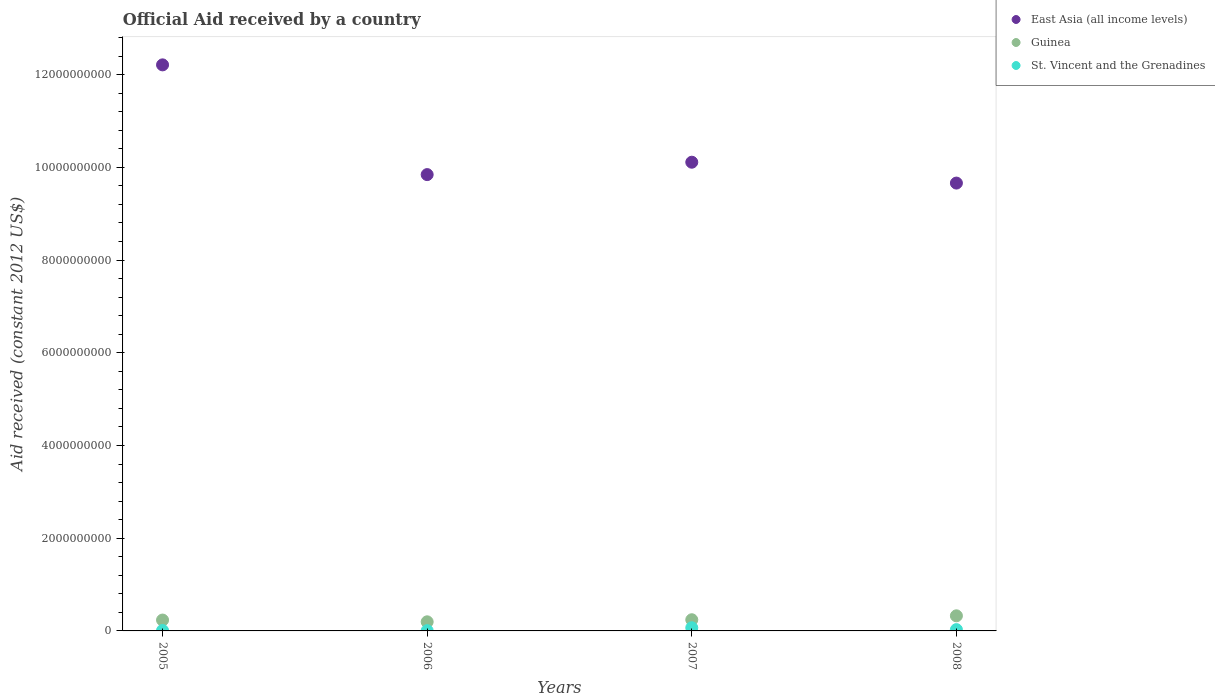How many different coloured dotlines are there?
Provide a short and direct response. 3. What is the net official aid received in St. Vincent and the Grenadines in 2007?
Offer a very short reply. 6.84e+07. Across all years, what is the maximum net official aid received in Guinea?
Your answer should be very brief. 3.26e+08. Across all years, what is the minimum net official aid received in St. Vincent and the Grenadines?
Keep it short and to the point. 5.68e+06. What is the total net official aid received in St. Vincent and the Grenadines in the graph?
Give a very brief answer. 1.12e+08. What is the difference between the net official aid received in Guinea in 2005 and that in 2006?
Provide a succinct answer. 3.81e+07. What is the difference between the net official aid received in Guinea in 2005 and the net official aid received in St. Vincent and the Grenadines in 2008?
Your answer should be compact. 2.06e+08. What is the average net official aid received in St. Vincent and the Grenadines per year?
Provide a short and direct response. 2.80e+07. In the year 2006, what is the difference between the net official aid received in East Asia (all income levels) and net official aid received in St. Vincent and the Grenadines?
Make the answer very short. 9.84e+09. In how many years, is the net official aid received in East Asia (all income levels) greater than 1200000000 US$?
Keep it short and to the point. 4. What is the ratio of the net official aid received in St. Vincent and the Grenadines in 2005 to that in 2006?
Keep it short and to the point. 1.72. Is the net official aid received in St. Vincent and the Grenadines in 2005 less than that in 2007?
Your answer should be compact. Yes. Is the difference between the net official aid received in East Asia (all income levels) in 2006 and 2008 greater than the difference between the net official aid received in St. Vincent and the Grenadines in 2006 and 2008?
Ensure brevity in your answer.  Yes. What is the difference between the highest and the second highest net official aid received in Guinea?
Provide a short and direct response. 8.46e+07. What is the difference between the highest and the lowest net official aid received in East Asia (all income levels)?
Provide a succinct answer. 2.55e+09. In how many years, is the net official aid received in St. Vincent and the Grenadines greater than the average net official aid received in St. Vincent and the Grenadines taken over all years?
Your answer should be very brief. 2. Is the sum of the net official aid received in St. Vincent and the Grenadines in 2007 and 2008 greater than the maximum net official aid received in Guinea across all years?
Ensure brevity in your answer.  No. Does the net official aid received in Guinea monotonically increase over the years?
Your answer should be very brief. No. Does the graph contain any zero values?
Give a very brief answer. No. Does the graph contain grids?
Your response must be concise. No. Where does the legend appear in the graph?
Offer a very short reply. Top right. How many legend labels are there?
Your answer should be very brief. 3. What is the title of the graph?
Ensure brevity in your answer.  Official Aid received by a country. What is the label or title of the Y-axis?
Offer a very short reply. Aid received (constant 2012 US$). What is the Aid received (constant 2012 US$) of East Asia (all income levels) in 2005?
Provide a short and direct response. 1.22e+1. What is the Aid received (constant 2012 US$) of Guinea in 2005?
Your response must be concise. 2.35e+08. What is the Aid received (constant 2012 US$) of St. Vincent and the Grenadines in 2005?
Your response must be concise. 9.75e+06. What is the Aid received (constant 2012 US$) of East Asia (all income levels) in 2006?
Ensure brevity in your answer.  9.84e+09. What is the Aid received (constant 2012 US$) of Guinea in 2006?
Your answer should be compact. 1.96e+08. What is the Aid received (constant 2012 US$) in St. Vincent and the Grenadines in 2006?
Give a very brief answer. 5.68e+06. What is the Aid received (constant 2012 US$) of East Asia (all income levels) in 2007?
Offer a terse response. 1.01e+1. What is the Aid received (constant 2012 US$) of Guinea in 2007?
Provide a succinct answer. 2.41e+08. What is the Aid received (constant 2012 US$) in St. Vincent and the Grenadines in 2007?
Give a very brief answer. 6.84e+07. What is the Aid received (constant 2012 US$) in East Asia (all income levels) in 2008?
Provide a succinct answer. 9.66e+09. What is the Aid received (constant 2012 US$) in Guinea in 2008?
Your answer should be very brief. 3.26e+08. What is the Aid received (constant 2012 US$) of St. Vincent and the Grenadines in 2008?
Make the answer very short. 2.82e+07. Across all years, what is the maximum Aid received (constant 2012 US$) in East Asia (all income levels)?
Your answer should be compact. 1.22e+1. Across all years, what is the maximum Aid received (constant 2012 US$) of Guinea?
Provide a short and direct response. 3.26e+08. Across all years, what is the maximum Aid received (constant 2012 US$) in St. Vincent and the Grenadines?
Offer a very short reply. 6.84e+07. Across all years, what is the minimum Aid received (constant 2012 US$) of East Asia (all income levels)?
Offer a very short reply. 9.66e+09. Across all years, what is the minimum Aid received (constant 2012 US$) of Guinea?
Give a very brief answer. 1.96e+08. Across all years, what is the minimum Aid received (constant 2012 US$) of St. Vincent and the Grenadines?
Your response must be concise. 5.68e+06. What is the total Aid received (constant 2012 US$) in East Asia (all income levels) in the graph?
Your answer should be very brief. 4.18e+1. What is the total Aid received (constant 2012 US$) of Guinea in the graph?
Offer a very short reply. 9.98e+08. What is the total Aid received (constant 2012 US$) in St. Vincent and the Grenadines in the graph?
Give a very brief answer. 1.12e+08. What is the difference between the Aid received (constant 2012 US$) in East Asia (all income levels) in 2005 and that in 2006?
Give a very brief answer. 2.37e+09. What is the difference between the Aid received (constant 2012 US$) in Guinea in 2005 and that in 2006?
Give a very brief answer. 3.81e+07. What is the difference between the Aid received (constant 2012 US$) of St. Vincent and the Grenadines in 2005 and that in 2006?
Your answer should be very brief. 4.07e+06. What is the difference between the Aid received (constant 2012 US$) in East Asia (all income levels) in 2005 and that in 2007?
Give a very brief answer. 2.10e+09. What is the difference between the Aid received (constant 2012 US$) in Guinea in 2005 and that in 2007?
Ensure brevity in your answer.  -6.56e+06. What is the difference between the Aid received (constant 2012 US$) of St. Vincent and the Grenadines in 2005 and that in 2007?
Provide a short and direct response. -5.87e+07. What is the difference between the Aid received (constant 2012 US$) of East Asia (all income levels) in 2005 and that in 2008?
Provide a succinct answer. 2.55e+09. What is the difference between the Aid received (constant 2012 US$) in Guinea in 2005 and that in 2008?
Provide a succinct answer. -9.11e+07. What is the difference between the Aid received (constant 2012 US$) of St. Vincent and the Grenadines in 2005 and that in 2008?
Offer a very short reply. -1.84e+07. What is the difference between the Aid received (constant 2012 US$) of East Asia (all income levels) in 2006 and that in 2007?
Keep it short and to the point. -2.67e+08. What is the difference between the Aid received (constant 2012 US$) in Guinea in 2006 and that in 2007?
Give a very brief answer. -4.46e+07. What is the difference between the Aid received (constant 2012 US$) in St. Vincent and the Grenadines in 2006 and that in 2007?
Your answer should be very brief. -6.27e+07. What is the difference between the Aid received (constant 2012 US$) of East Asia (all income levels) in 2006 and that in 2008?
Offer a terse response. 1.83e+08. What is the difference between the Aid received (constant 2012 US$) in Guinea in 2006 and that in 2008?
Offer a very short reply. -1.29e+08. What is the difference between the Aid received (constant 2012 US$) of St. Vincent and the Grenadines in 2006 and that in 2008?
Provide a succinct answer. -2.25e+07. What is the difference between the Aid received (constant 2012 US$) in East Asia (all income levels) in 2007 and that in 2008?
Make the answer very short. 4.50e+08. What is the difference between the Aid received (constant 2012 US$) in Guinea in 2007 and that in 2008?
Offer a very short reply. -8.46e+07. What is the difference between the Aid received (constant 2012 US$) of St. Vincent and the Grenadines in 2007 and that in 2008?
Offer a terse response. 4.02e+07. What is the difference between the Aid received (constant 2012 US$) in East Asia (all income levels) in 2005 and the Aid received (constant 2012 US$) in Guinea in 2006?
Your answer should be compact. 1.20e+1. What is the difference between the Aid received (constant 2012 US$) of East Asia (all income levels) in 2005 and the Aid received (constant 2012 US$) of St. Vincent and the Grenadines in 2006?
Keep it short and to the point. 1.22e+1. What is the difference between the Aid received (constant 2012 US$) of Guinea in 2005 and the Aid received (constant 2012 US$) of St. Vincent and the Grenadines in 2006?
Your response must be concise. 2.29e+08. What is the difference between the Aid received (constant 2012 US$) in East Asia (all income levels) in 2005 and the Aid received (constant 2012 US$) in Guinea in 2007?
Provide a short and direct response. 1.20e+1. What is the difference between the Aid received (constant 2012 US$) of East Asia (all income levels) in 2005 and the Aid received (constant 2012 US$) of St. Vincent and the Grenadines in 2007?
Offer a terse response. 1.21e+1. What is the difference between the Aid received (constant 2012 US$) of Guinea in 2005 and the Aid received (constant 2012 US$) of St. Vincent and the Grenadines in 2007?
Your answer should be very brief. 1.66e+08. What is the difference between the Aid received (constant 2012 US$) in East Asia (all income levels) in 2005 and the Aid received (constant 2012 US$) in Guinea in 2008?
Make the answer very short. 1.19e+1. What is the difference between the Aid received (constant 2012 US$) in East Asia (all income levels) in 2005 and the Aid received (constant 2012 US$) in St. Vincent and the Grenadines in 2008?
Your response must be concise. 1.22e+1. What is the difference between the Aid received (constant 2012 US$) in Guinea in 2005 and the Aid received (constant 2012 US$) in St. Vincent and the Grenadines in 2008?
Provide a short and direct response. 2.06e+08. What is the difference between the Aid received (constant 2012 US$) in East Asia (all income levels) in 2006 and the Aid received (constant 2012 US$) in Guinea in 2007?
Give a very brief answer. 9.60e+09. What is the difference between the Aid received (constant 2012 US$) of East Asia (all income levels) in 2006 and the Aid received (constant 2012 US$) of St. Vincent and the Grenadines in 2007?
Offer a terse response. 9.77e+09. What is the difference between the Aid received (constant 2012 US$) in Guinea in 2006 and the Aid received (constant 2012 US$) in St. Vincent and the Grenadines in 2007?
Your response must be concise. 1.28e+08. What is the difference between the Aid received (constant 2012 US$) of East Asia (all income levels) in 2006 and the Aid received (constant 2012 US$) of Guinea in 2008?
Keep it short and to the point. 9.52e+09. What is the difference between the Aid received (constant 2012 US$) in East Asia (all income levels) in 2006 and the Aid received (constant 2012 US$) in St. Vincent and the Grenadines in 2008?
Provide a succinct answer. 9.81e+09. What is the difference between the Aid received (constant 2012 US$) in Guinea in 2006 and the Aid received (constant 2012 US$) in St. Vincent and the Grenadines in 2008?
Provide a short and direct response. 1.68e+08. What is the difference between the Aid received (constant 2012 US$) in East Asia (all income levels) in 2007 and the Aid received (constant 2012 US$) in Guinea in 2008?
Provide a short and direct response. 9.78e+09. What is the difference between the Aid received (constant 2012 US$) of East Asia (all income levels) in 2007 and the Aid received (constant 2012 US$) of St. Vincent and the Grenadines in 2008?
Offer a very short reply. 1.01e+1. What is the difference between the Aid received (constant 2012 US$) of Guinea in 2007 and the Aid received (constant 2012 US$) of St. Vincent and the Grenadines in 2008?
Your answer should be compact. 2.13e+08. What is the average Aid received (constant 2012 US$) in East Asia (all income levels) per year?
Offer a terse response. 1.05e+1. What is the average Aid received (constant 2012 US$) of Guinea per year?
Your answer should be very brief. 2.49e+08. What is the average Aid received (constant 2012 US$) in St. Vincent and the Grenadines per year?
Provide a short and direct response. 2.80e+07. In the year 2005, what is the difference between the Aid received (constant 2012 US$) in East Asia (all income levels) and Aid received (constant 2012 US$) in Guinea?
Your answer should be compact. 1.20e+1. In the year 2005, what is the difference between the Aid received (constant 2012 US$) in East Asia (all income levels) and Aid received (constant 2012 US$) in St. Vincent and the Grenadines?
Your answer should be very brief. 1.22e+1. In the year 2005, what is the difference between the Aid received (constant 2012 US$) of Guinea and Aid received (constant 2012 US$) of St. Vincent and the Grenadines?
Your response must be concise. 2.25e+08. In the year 2006, what is the difference between the Aid received (constant 2012 US$) of East Asia (all income levels) and Aid received (constant 2012 US$) of Guinea?
Your answer should be very brief. 9.65e+09. In the year 2006, what is the difference between the Aid received (constant 2012 US$) in East Asia (all income levels) and Aid received (constant 2012 US$) in St. Vincent and the Grenadines?
Your answer should be very brief. 9.84e+09. In the year 2006, what is the difference between the Aid received (constant 2012 US$) of Guinea and Aid received (constant 2012 US$) of St. Vincent and the Grenadines?
Your answer should be compact. 1.91e+08. In the year 2007, what is the difference between the Aid received (constant 2012 US$) in East Asia (all income levels) and Aid received (constant 2012 US$) in Guinea?
Keep it short and to the point. 9.87e+09. In the year 2007, what is the difference between the Aid received (constant 2012 US$) of East Asia (all income levels) and Aid received (constant 2012 US$) of St. Vincent and the Grenadines?
Your response must be concise. 1.00e+1. In the year 2007, what is the difference between the Aid received (constant 2012 US$) in Guinea and Aid received (constant 2012 US$) in St. Vincent and the Grenadines?
Provide a succinct answer. 1.73e+08. In the year 2008, what is the difference between the Aid received (constant 2012 US$) in East Asia (all income levels) and Aid received (constant 2012 US$) in Guinea?
Offer a very short reply. 9.33e+09. In the year 2008, what is the difference between the Aid received (constant 2012 US$) in East Asia (all income levels) and Aid received (constant 2012 US$) in St. Vincent and the Grenadines?
Give a very brief answer. 9.63e+09. In the year 2008, what is the difference between the Aid received (constant 2012 US$) in Guinea and Aid received (constant 2012 US$) in St. Vincent and the Grenadines?
Give a very brief answer. 2.98e+08. What is the ratio of the Aid received (constant 2012 US$) in East Asia (all income levels) in 2005 to that in 2006?
Give a very brief answer. 1.24. What is the ratio of the Aid received (constant 2012 US$) of Guinea in 2005 to that in 2006?
Provide a short and direct response. 1.19. What is the ratio of the Aid received (constant 2012 US$) of St. Vincent and the Grenadines in 2005 to that in 2006?
Give a very brief answer. 1.72. What is the ratio of the Aid received (constant 2012 US$) of East Asia (all income levels) in 2005 to that in 2007?
Keep it short and to the point. 1.21. What is the ratio of the Aid received (constant 2012 US$) of Guinea in 2005 to that in 2007?
Offer a terse response. 0.97. What is the ratio of the Aid received (constant 2012 US$) in St. Vincent and the Grenadines in 2005 to that in 2007?
Offer a very short reply. 0.14. What is the ratio of the Aid received (constant 2012 US$) of East Asia (all income levels) in 2005 to that in 2008?
Give a very brief answer. 1.26. What is the ratio of the Aid received (constant 2012 US$) in Guinea in 2005 to that in 2008?
Make the answer very short. 0.72. What is the ratio of the Aid received (constant 2012 US$) in St. Vincent and the Grenadines in 2005 to that in 2008?
Ensure brevity in your answer.  0.35. What is the ratio of the Aid received (constant 2012 US$) in East Asia (all income levels) in 2006 to that in 2007?
Provide a succinct answer. 0.97. What is the ratio of the Aid received (constant 2012 US$) of Guinea in 2006 to that in 2007?
Offer a terse response. 0.81. What is the ratio of the Aid received (constant 2012 US$) in St. Vincent and the Grenadines in 2006 to that in 2007?
Make the answer very short. 0.08. What is the ratio of the Aid received (constant 2012 US$) in East Asia (all income levels) in 2006 to that in 2008?
Provide a short and direct response. 1.02. What is the ratio of the Aid received (constant 2012 US$) of Guinea in 2006 to that in 2008?
Your response must be concise. 0.6. What is the ratio of the Aid received (constant 2012 US$) of St. Vincent and the Grenadines in 2006 to that in 2008?
Keep it short and to the point. 0.2. What is the ratio of the Aid received (constant 2012 US$) of East Asia (all income levels) in 2007 to that in 2008?
Keep it short and to the point. 1.05. What is the ratio of the Aid received (constant 2012 US$) in Guinea in 2007 to that in 2008?
Offer a very short reply. 0.74. What is the ratio of the Aid received (constant 2012 US$) in St. Vincent and the Grenadines in 2007 to that in 2008?
Keep it short and to the point. 2.43. What is the difference between the highest and the second highest Aid received (constant 2012 US$) in East Asia (all income levels)?
Give a very brief answer. 2.10e+09. What is the difference between the highest and the second highest Aid received (constant 2012 US$) of Guinea?
Your answer should be compact. 8.46e+07. What is the difference between the highest and the second highest Aid received (constant 2012 US$) in St. Vincent and the Grenadines?
Keep it short and to the point. 4.02e+07. What is the difference between the highest and the lowest Aid received (constant 2012 US$) of East Asia (all income levels)?
Your answer should be compact. 2.55e+09. What is the difference between the highest and the lowest Aid received (constant 2012 US$) of Guinea?
Give a very brief answer. 1.29e+08. What is the difference between the highest and the lowest Aid received (constant 2012 US$) of St. Vincent and the Grenadines?
Provide a short and direct response. 6.27e+07. 